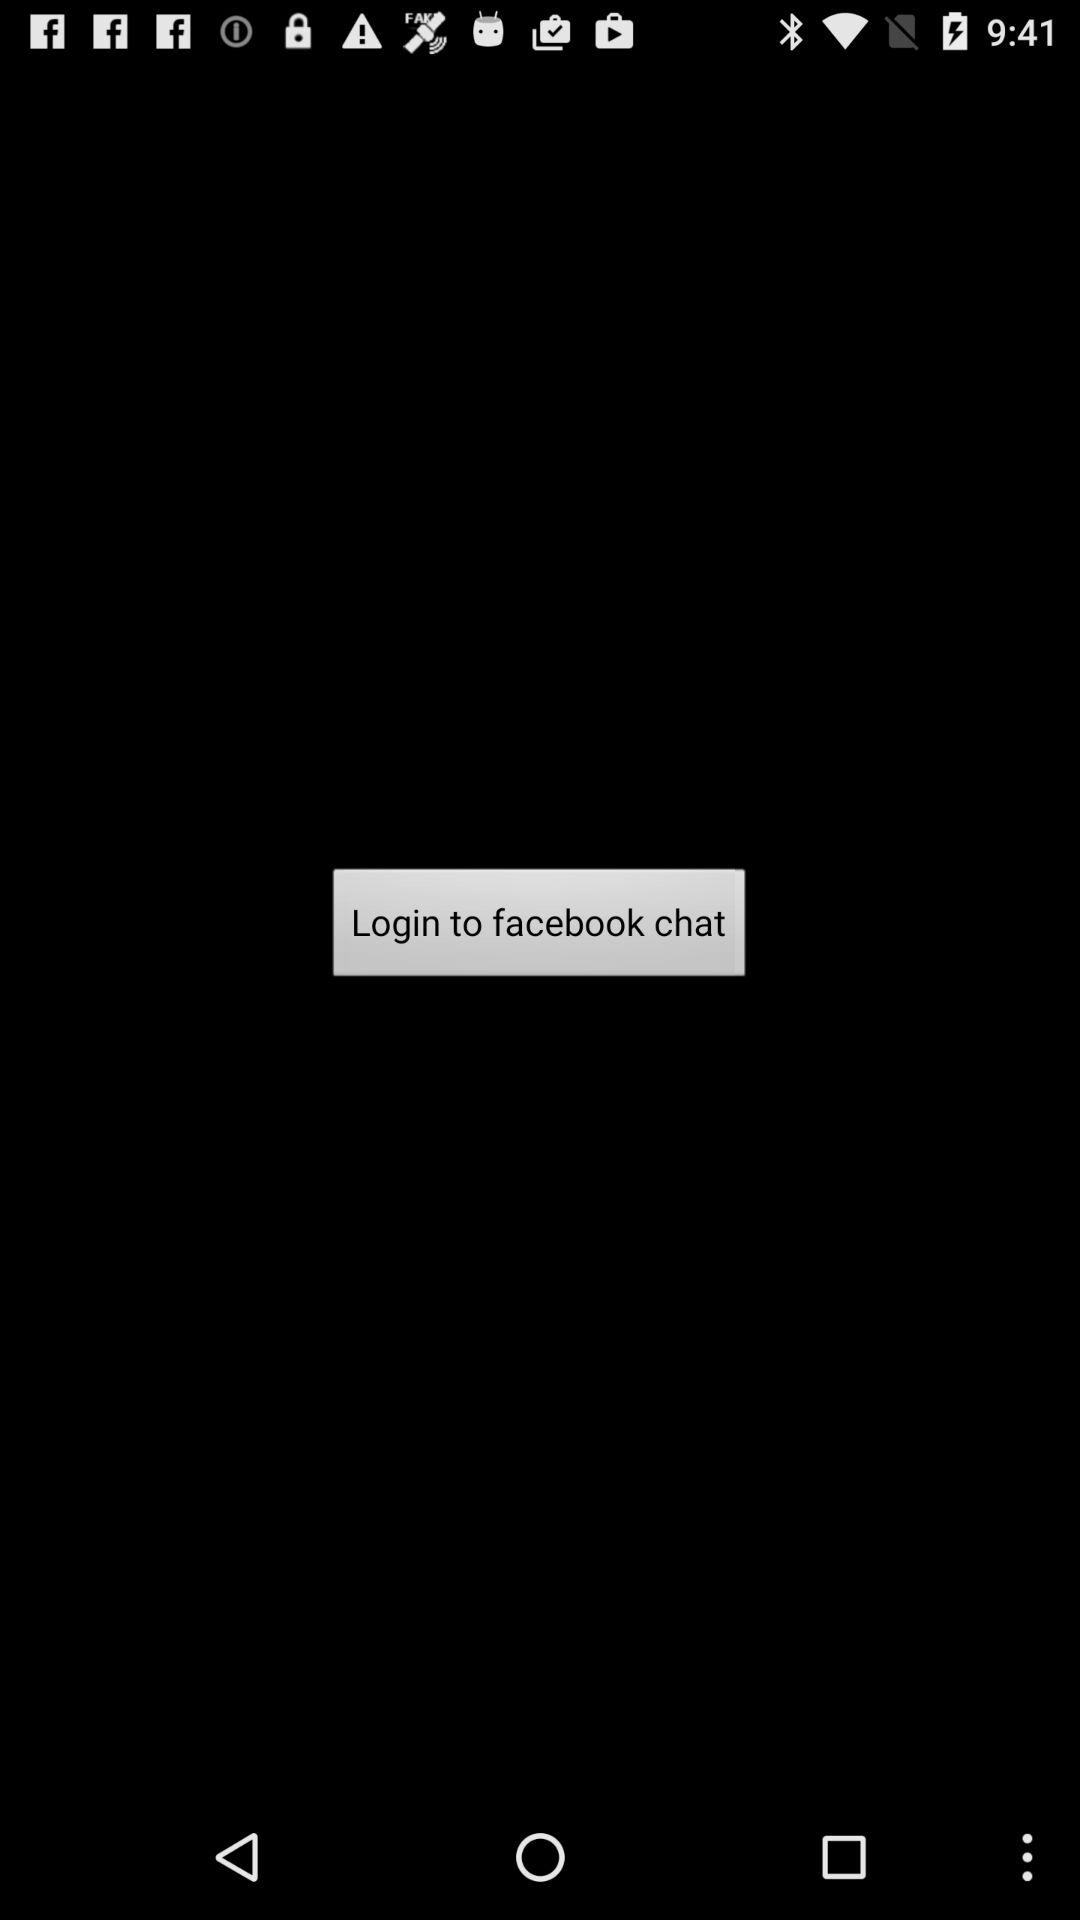Where can we log in? You can log in to "facebook". 